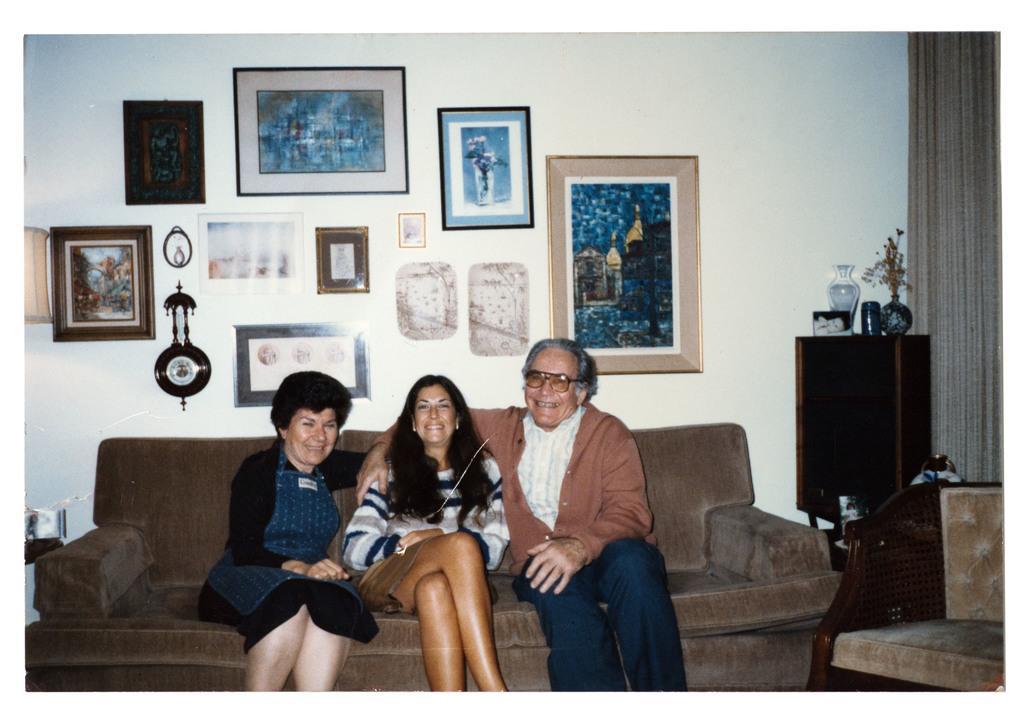How would you summarize this image in a sentence or two? In this picture we can see three people sitting on a sofa, they are smiling and in the background we can see a wall, photo frames, clock, flower vase, curtain and some objects. 